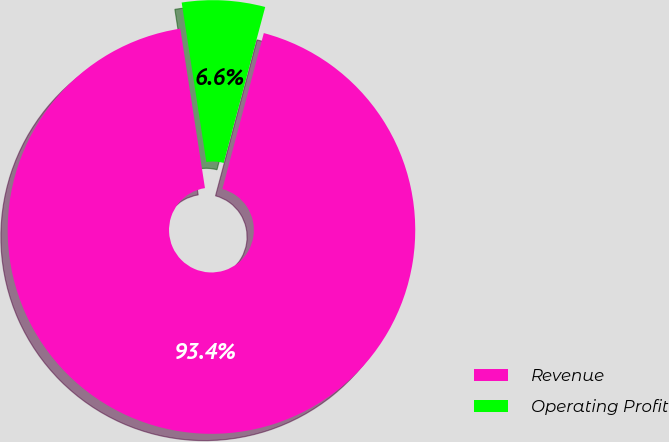<chart> <loc_0><loc_0><loc_500><loc_500><pie_chart><fcel>Revenue<fcel>Operating Profit<nl><fcel>93.42%<fcel>6.58%<nl></chart> 